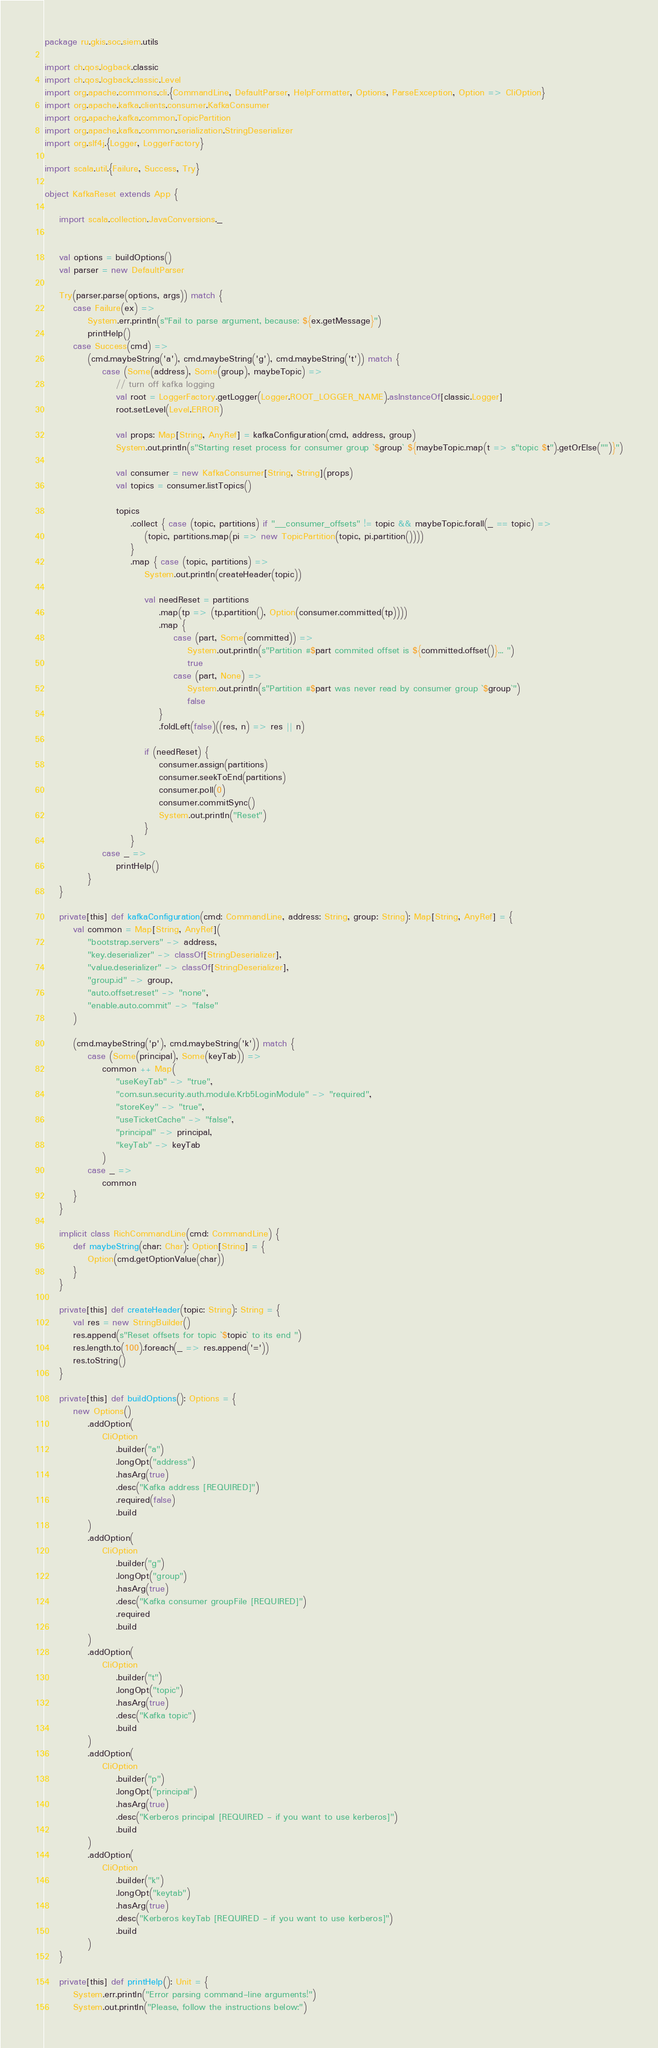<code> <loc_0><loc_0><loc_500><loc_500><_Scala_>package ru.gkis.soc.siem.utils

import ch.qos.logback.classic
import ch.qos.logback.classic.Level
import org.apache.commons.cli.{CommandLine, DefaultParser, HelpFormatter, Options, ParseException, Option => CliOption}
import org.apache.kafka.clients.consumer.KafkaConsumer
import org.apache.kafka.common.TopicPartition
import org.apache.kafka.common.serialization.StringDeserializer
import org.slf4j.{Logger, LoggerFactory}

import scala.util.{Failure, Success, Try}

object KafkaReset extends App {

    import scala.collection.JavaConversions._


    val options = buildOptions()
    val parser = new DefaultParser

    Try(parser.parse(options, args)) match {
        case Failure(ex) =>
            System.err.println(s"Fail to parse argument, because: ${ex.getMessage}")
            printHelp()
        case Success(cmd) =>
            (cmd.maybeString('a'), cmd.maybeString('g'), cmd.maybeString('t')) match {
                case (Some(address), Some(group), maybeTopic) =>
                    // turn off kafka logging
                    val root = LoggerFactory.getLogger(Logger.ROOT_LOGGER_NAME).asInstanceOf[classic.Logger]
                    root.setLevel(Level.ERROR)

                    val props: Map[String, AnyRef] = kafkaConfiguration(cmd, address, group)
                    System.out.println(s"Starting reset process for consumer group `$group` ${maybeTopic.map(t => s"topic $t").getOrElse("")}")

                    val consumer = new KafkaConsumer[String, String](props)
                    val topics = consumer.listTopics()

                    topics
                        .collect { case (topic, partitions) if "__consumer_offsets" != topic && maybeTopic.forall(_ == topic) =>
                            (topic, partitions.map(pi => new TopicPartition(topic, pi.partition())))
                        }
                        .map { case (topic, partitions) =>
                            System.out.println(createHeader(topic))

                            val needReset = partitions
                                .map(tp => (tp.partition(), Option(consumer.committed(tp))))
                                .map {
                                    case (part, Some(committed)) =>
                                        System.out.println(s"Partition #$part commited offset is ${committed.offset()}... ")
                                        true
                                    case (part, None) =>
                                        System.out.println(s"Partition #$part was never read by consumer group `$group`")
                                        false
                                }
                                .foldLeft(false)((res, n) => res || n)

                            if (needReset) {
                                consumer.assign(partitions)
                                consumer.seekToEnd(partitions)
                                consumer.poll(0)
                                consumer.commitSync()
                                System.out.println("Reset")
                            }
                        }
                case _ =>
                    printHelp()
            }
    }

    private[this] def kafkaConfiguration(cmd: CommandLine, address: String, group: String): Map[String, AnyRef] = {
        val common = Map[String, AnyRef](
            "bootstrap.servers" -> address,
            "key.deserializer" -> classOf[StringDeserializer],
            "value.deserializer" -> classOf[StringDeserializer],
            "group.id" -> group,
            "auto.offset.reset" -> "none",
            "enable.auto.commit" -> "false"
        )

        (cmd.maybeString('p'), cmd.maybeString('k')) match {
            case (Some(principal), Some(keyTab)) =>
                common ++ Map(
                    "useKeyTab" -> "true",
                    "com.sun.security.auth.module.Krb5LoginModule" -> "required",
                    "storeKey" -> "true",
                    "useTicketCache" -> "false",
                    "principal" -> principal,
                    "keyTab" -> keyTab
                )
            case _ =>
                common
        }
    }

    implicit class RichCommandLine(cmd: CommandLine) {
        def maybeString(char: Char): Option[String] = {
            Option(cmd.getOptionValue(char))
        }
    }

    private[this] def createHeader(topic: String): String = {
        val res = new StringBuilder()
        res.append(s"Reset offsets for topic `$topic` to its end ")
        res.length.to(100).foreach(_ => res.append('='))
        res.toString()
    }

    private[this] def buildOptions(): Options = {
        new Options()
            .addOption(
                CliOption
                    .builder("a")
                    .longOpt("address")
                    .hasArg(true)
                    .desc("Kafka address [REQUIRED]")
                    .required(false)
                    .build
            )
            .addOption(
                CliOption
                    .builder("g")
                    .longOpt("group")
                    .hasArg(true)
                    .desc("Kafka consumer groupFile [REQUIRED]")
                    .required
                    .build
            )
            .addOption(
                CliOption
                    .builder("t")
                    .longOpt("topic")
                    .hasArg(true)
                    .desc("Kafka topic")
                    .build
            )
            .addOption(
                CliOption
                    .builder("p")
                    .longOpt("principal")
                    .hasArg(true)
                    .desc("Kerberos principal [REQUIRED - if you want to use kerberos]")
                    .build
            )
            .addOption(
                CliOption
                    .builder("k")
                    .longOpt("keytab")
                    .hasArg(true)
                    .desc("Kerberos keyTab [REQUIRED - if you want to use kerberos]")
                    .build
            )
    }

    private[this] def printHelp(): Unit = {
        System.err.println("Error parsing command-line arguments!")
        System.out.println("Please, follow the instructions below:")</code> 